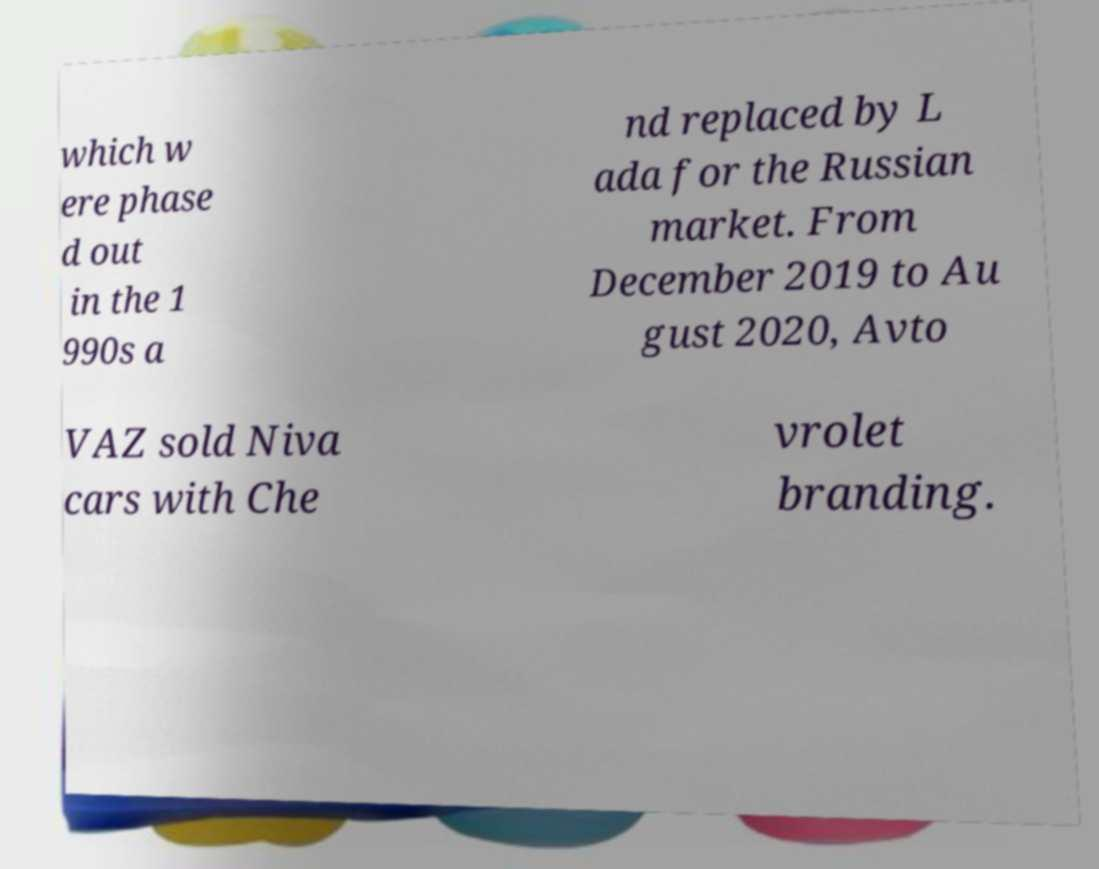Could you assist in decoding the text presented in this image and type it out clearly? which w ere phase d out in the 1 990s a nd replaced by L ada for the Russian market. From December 2019 to Au gust 2020, Avto VAZ sold Niva cars with Che vrolet branding. 